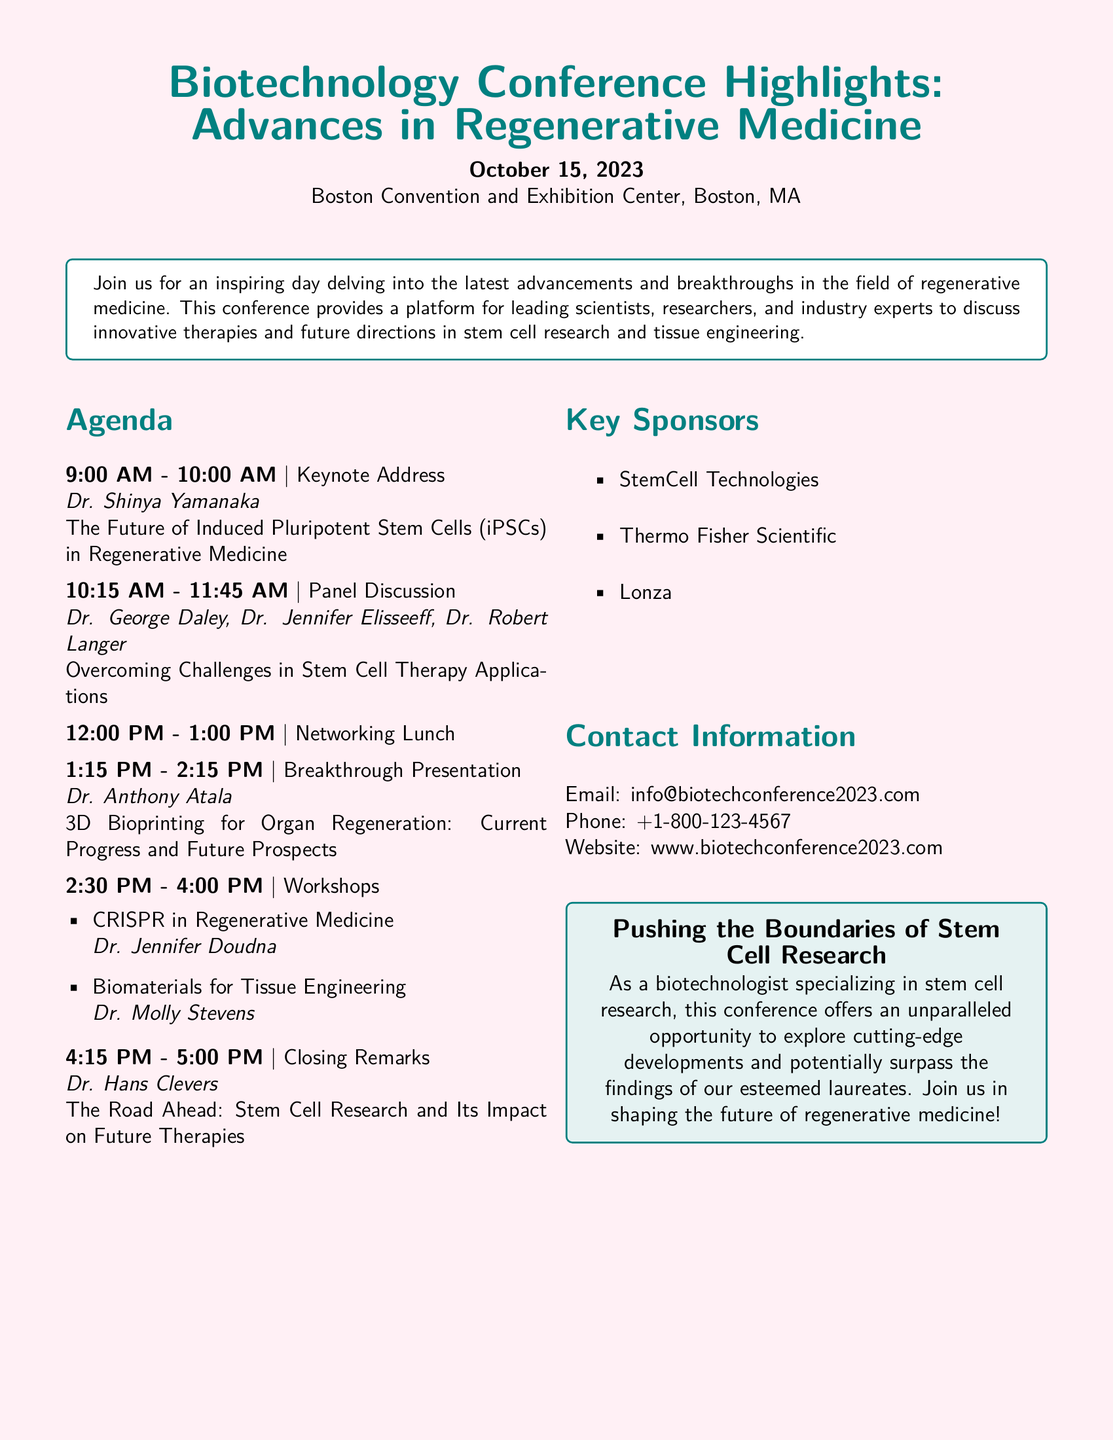What is the date of the conference? The date is clearly stated in the document as October 15, 2023.
Answer: October 15, 2023 Who is the keynote speaker? The document introduces Dr. Shinya Yamanaka as the keynote speaker for the conference.
Answer: Dr. Shinya Yamanaka What is the title of the keynote address? The title of the keynote address given by Dr. Shinya Yamanaka is mentioned in the agenda section.
Answer: The Future of Induced Pluripotent Stem Cells in Regenerative Medicine How many workshops are listed in the agenda? The number of workshops can be counted from the agenda, which indicates two workshops.
Answer: 2 Who is presenting on 3D Bioprinting? The document specifies Dr. Anthony Atala as the presenter for the breakthrough presentation on 3D bioprinting.
Answer: Dr. Anthony Atala What is one of the key sponsors mentioned? The document lists several key sponsors, and any one from that list can be provided as an answer.
Answer: StemCell Technologies What time does the networking lunch start? The schedule specifically states the networking lunch time is from 12:00 PM to 1:00 PM.
Answer: 12:00 PM What is the main theme of the conference? The overall theme is highlighted in the introduction as it discusses advancements and breakthroughs in regenerative medicine.
Answer: Advances in Regenerative Medicine What is the focus of the closing remarks? The focus of the closing remarks by Dr. Hans Clevers is detailed in the agenda.
Answer: Stem Cell Research and Its Impact on Future Therapies 